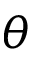Convert formula to latex. <formula><loc_0><loc_0><loc_500><loc_500>\theta</formula> 